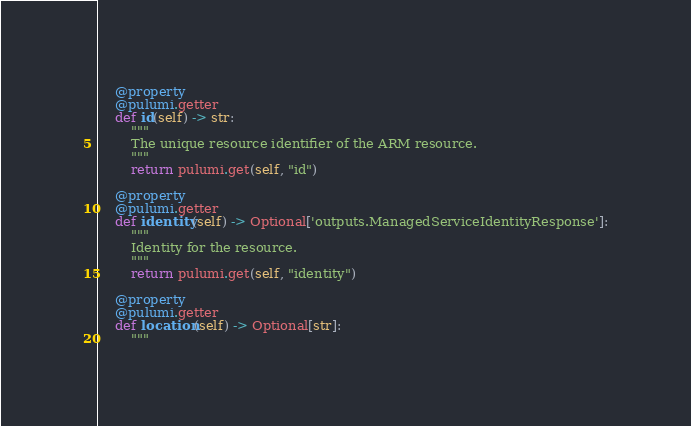<code> <loc_0><loc_0><loc_500><loc_500><_Python_>
    @property
    @pulumi.getter
    def id(self) -> str:
        """
        The unique resource identifier of the ARM resource.
        """
        return pulumi.get(self, "id")

    @property
    @pulumi.getter
    def identity(self) -> Optional['outputs.ManagedServiceIdentityResponse']:
        """
        Identity for the resource.
        """
        return pulumi.get(self, "identity")

    @property
    @pulumi.getter
    def location(self) -> Optional[str]:
        """</code> 